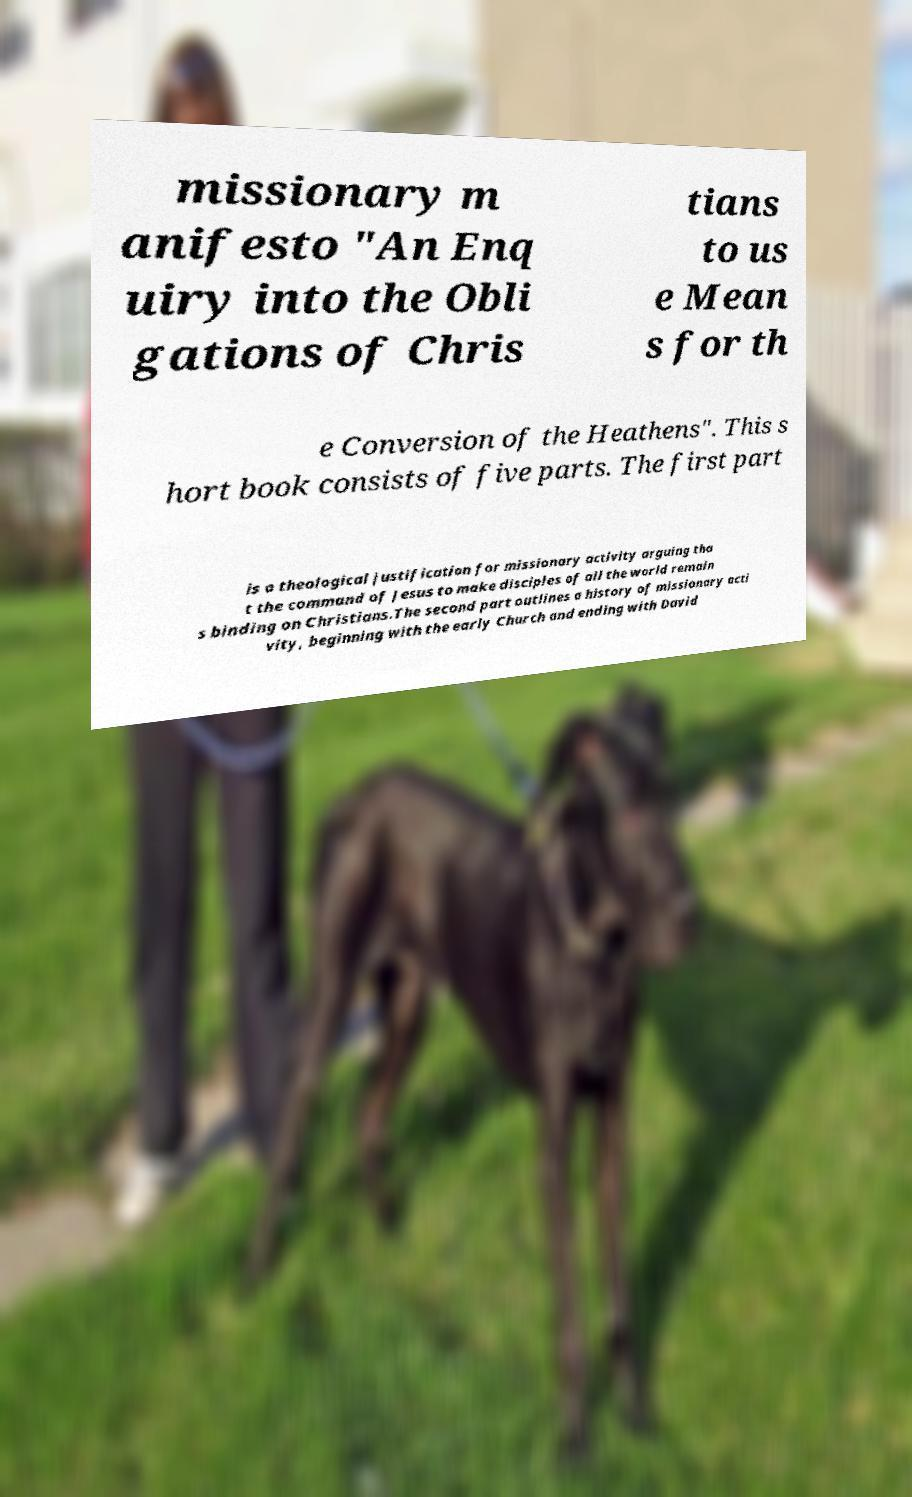I need the written content from this picture converted into text. Can you do that? missionary m anifesto "An Enq uiry into the Obli gations of Chris tians to us e Mean s for th e Conversion of the Heathens". This s hort book consists of five parts. The first part is a theological justification for missionary activity arguing tha t the command of Jesus to make disciples of all the world remain s binding on Christians.The second part outlines a history of missionary acti vity, beginning with the early Church and ending with David 